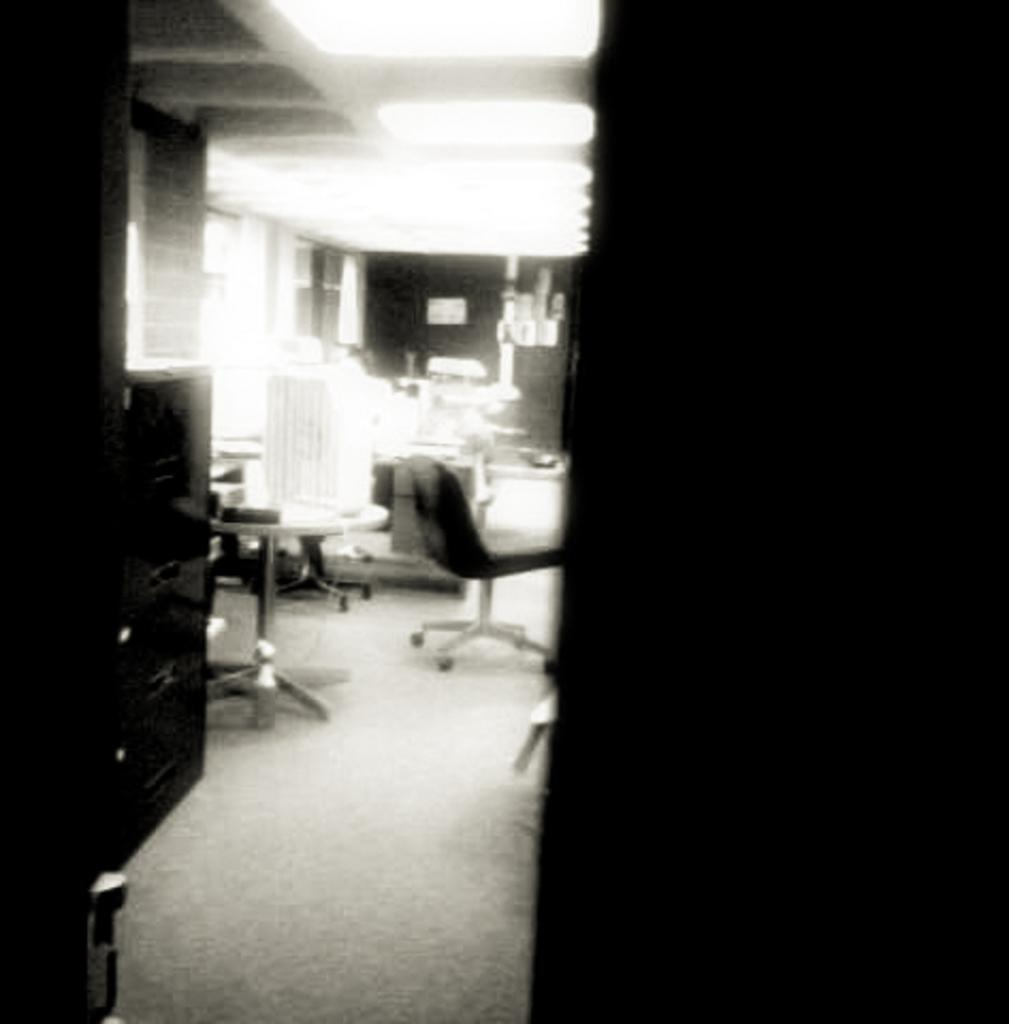What type of furniture is present in the image? There are chairs and tables in the image. Are there any objects on the floor in the image? Yes, there are objects on the floor in the image. What is the color scheme of the image? The image is black and white in color. Can you describe the crook in the image? There is no crook present in the image. What type of jellyfish can be seen swimming in the image? There is no jellyfish present in the image; it is a black and white image featuring chairs, tables, and objects on the floor. 